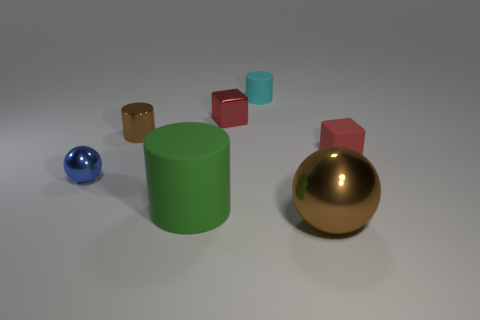Add 1 blue shiny cylinders. How many objects exist? 8 Subtract all spheres. How many objects are left? 5 Subtract all big brown matte objects. Subtract all cyan cylinders. How many objects are left? 6 Add 7 large objects. How many large objects are left? 9 Add 1 small cyan matte balls. How many small cyan matte balls exist? 1 Subtract 0 blue cubes. How many objects are left? 7 